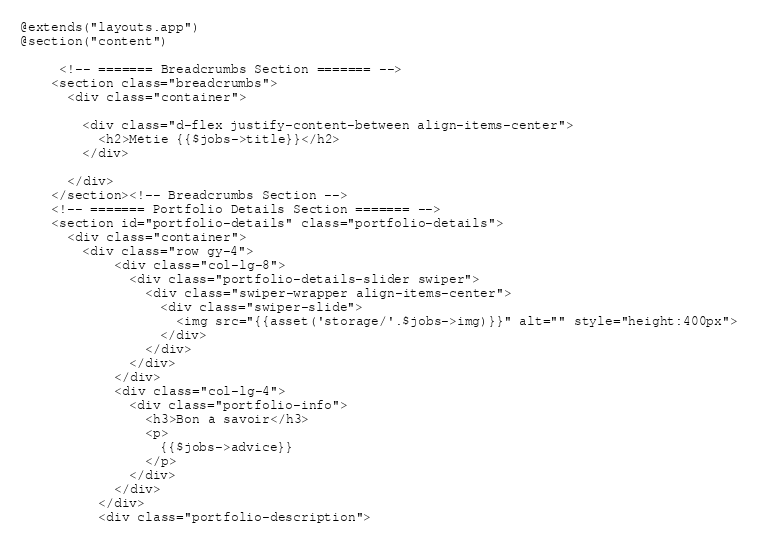Convert code to text. <code><loc_0><loc_0><loc_500><loc_500><_PHP_>@extends("layouts.app")
@section("content")

     <!-- ======= Breadcrumbs Section ======= -->
    <section class="breadcrumbs">
      <div class="container">

        <div class="d-flex justify-content-between align-items-center">
          <h2>Métie {{$jobs->title}}</h2>
        </div>

      </div>
    </section><!-- Breadcrumbs Section -->
    <!-- ======= Portfolio Details Section ======= -->
    <section id="portfolio-details" class="portfolio-details">
      <div class="container">
        <div class="row gy-4">
            <div class="col-lg-8">
              <div class="portfolio-details-slider swiper">
                <div class="swiper-wrapper align-items-center">
                  <div class="swiper-slide">
                    <img src="{{asset('storage/'.$jobs->img)}}" alt="" style="height:400px">
                  </div>
                </div>
              </div>
            </div>
            <div class="col-lg-4">
              <div class="portfolio-info">
                <h3>Bon à savoir</h3>
                <p>
                  {{$jobs->advice}}
                </p>
              </div>
            </div>
          </div>
          <div class="portfolio-description"></code> 